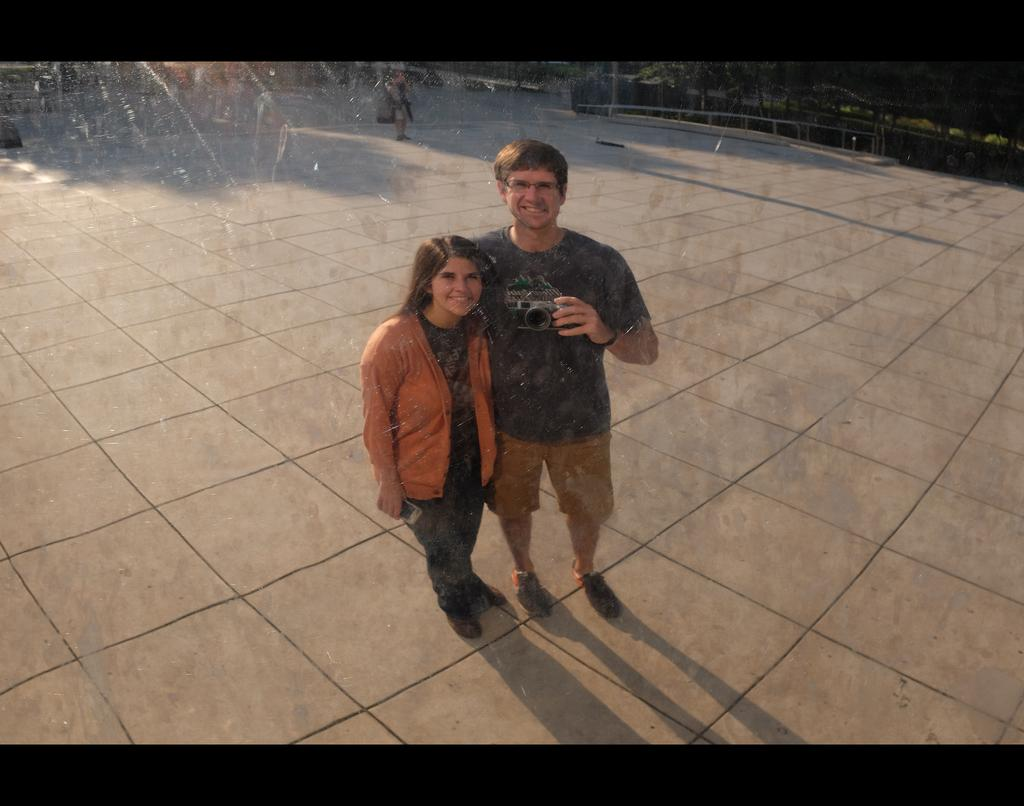How many persons are in the image? There are persons standing in the image. What are the persons holding in the image? The persons are holding a cell phone and a camera. What can be seen in the background of the image? There is a fence, plants, and trees in the background of the image. What is the opinion of the school in the image? There is no school present in the image, so it is not possible to determine an opinion about it. 